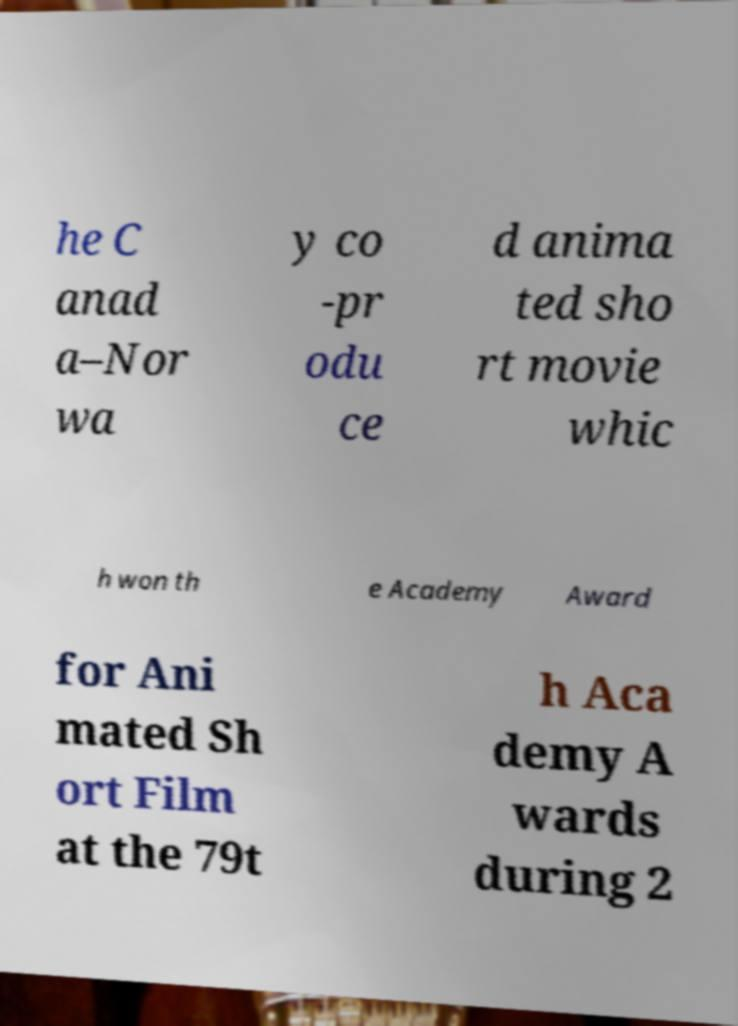Can you read and provide the text displayed in the image?This photo seems to have some interesting text. Can you extract and type it out for me? he C anad a–Nor wa y co -pr odu ce d anima ted sho rt movie whic h won th e Academy Award for Ani mated Sh ort Film at the 79t h Aca demy A wards during 2 